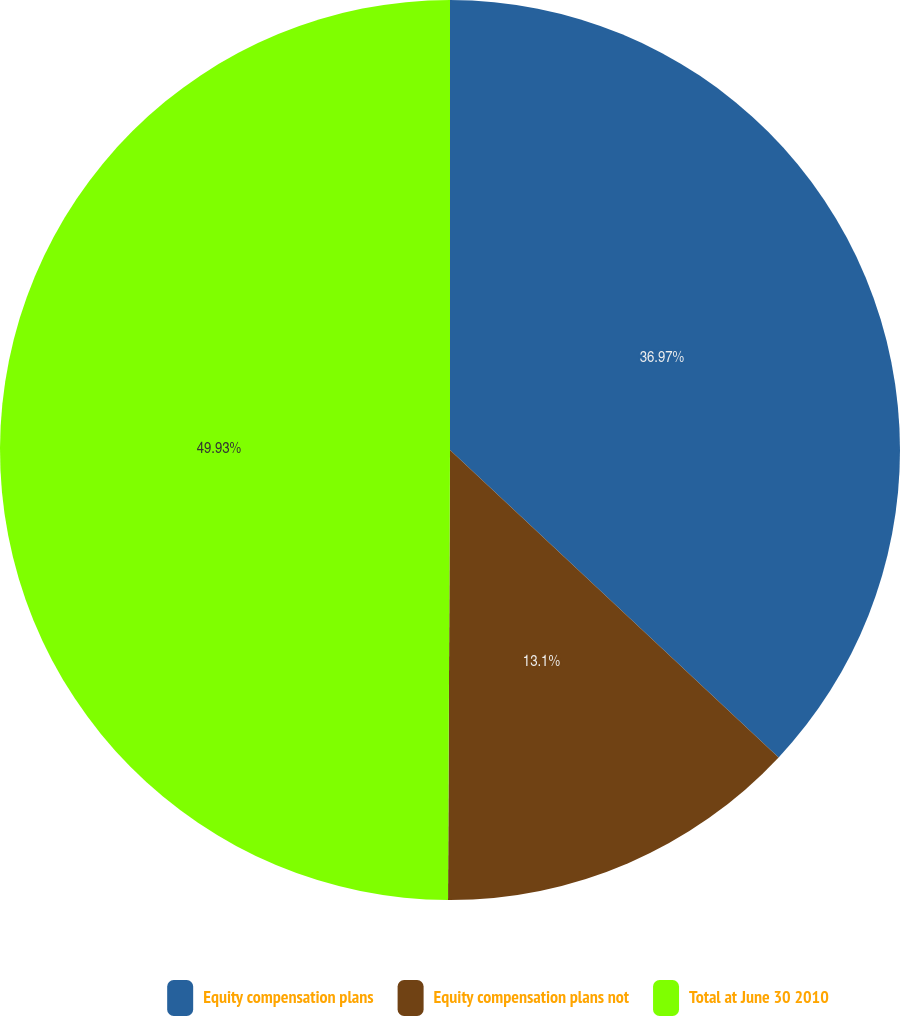Convert chart to OTSL. <chart><loc_0><loc_0><loc_500><loc_500><pie_chart><fcel>Equity compensation plans<fcel>Equity compensation plans not<fcel>Total at June 30 2010<nl><fcel>36.97%<fcel>13.1%<fcel>49.93%<nl></chart> 